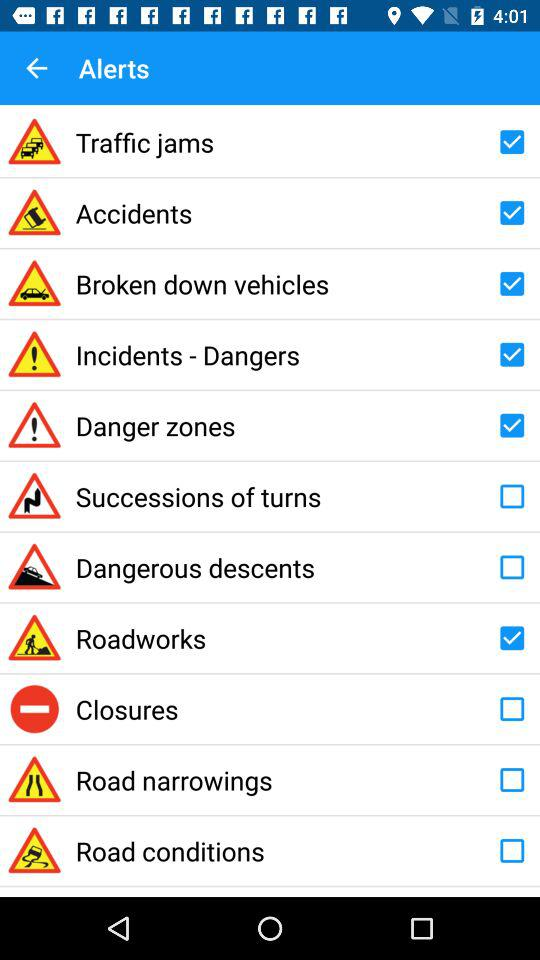What are the selected alerts? The selected alerts are "Traffic jams", "Accidents", "Broken down vehicles", "Incidents - Dangers", "Danger zones" and "Roadworks". 